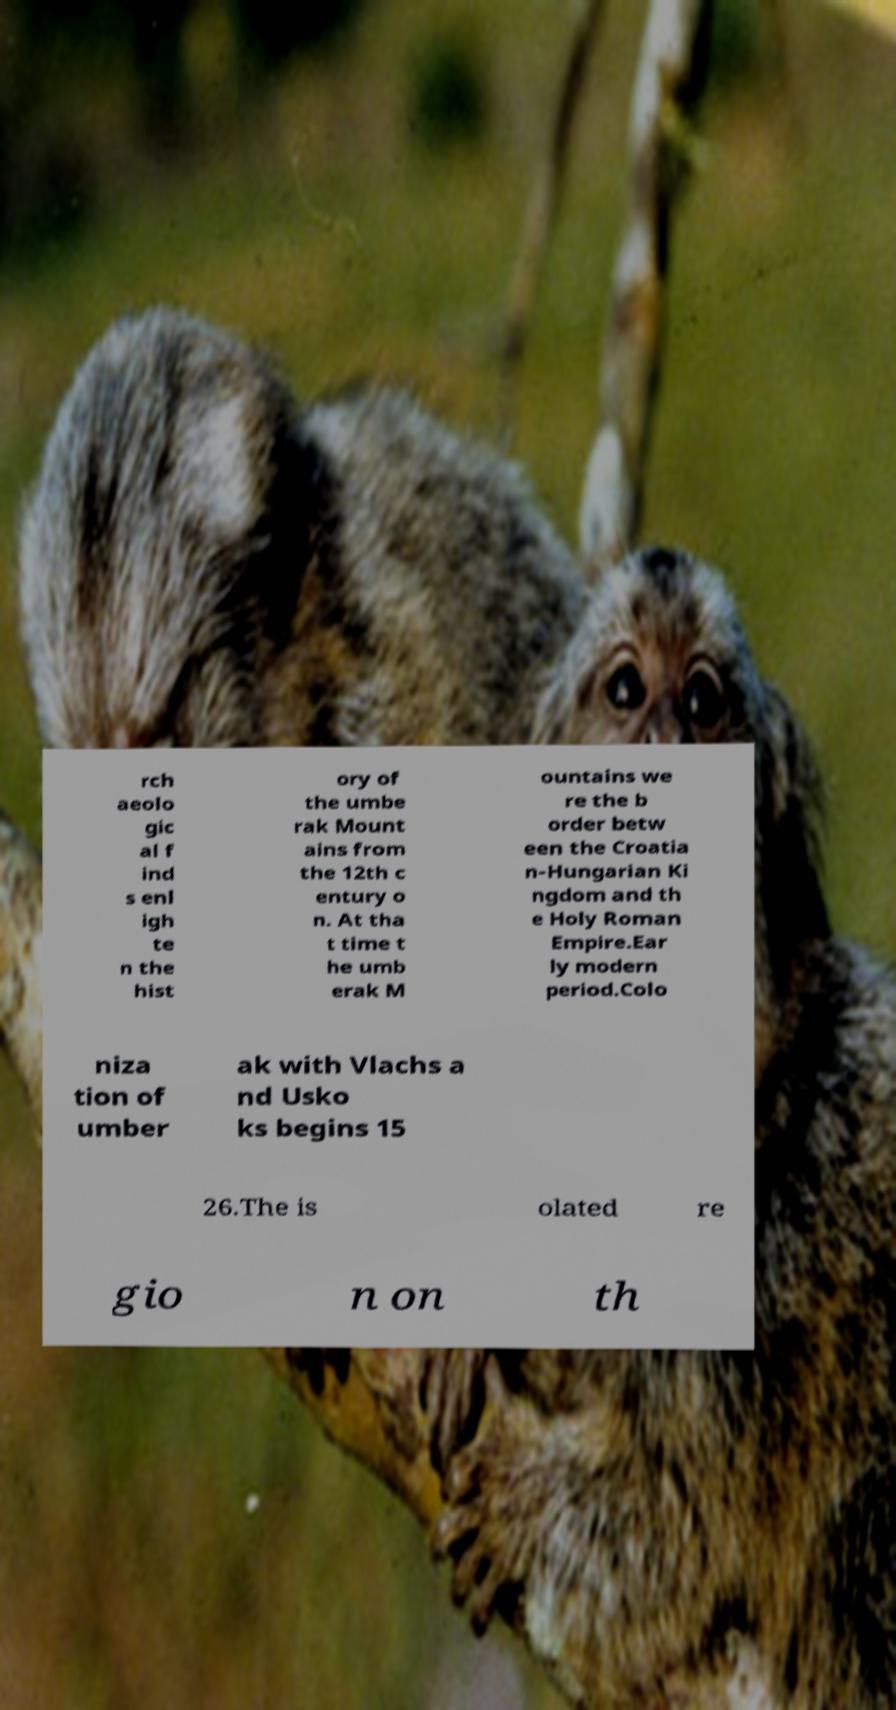Can you accurately transcribe the text from the provided image for me? rch aeolo gic al f ind s enl igh te n the hist ory of the umbe rak Mount ains from the 12th c entury o n. At tha t time t he umb erak M ountains we re the b order betw een the Croatia n-Hungarian Ki ngdom and th e Holy Roman Empire.Ear ly modern period.Colo niza tion of umber ak with Vlachs a nd Usko ks begins 15 26.The is olated re gio n on th 